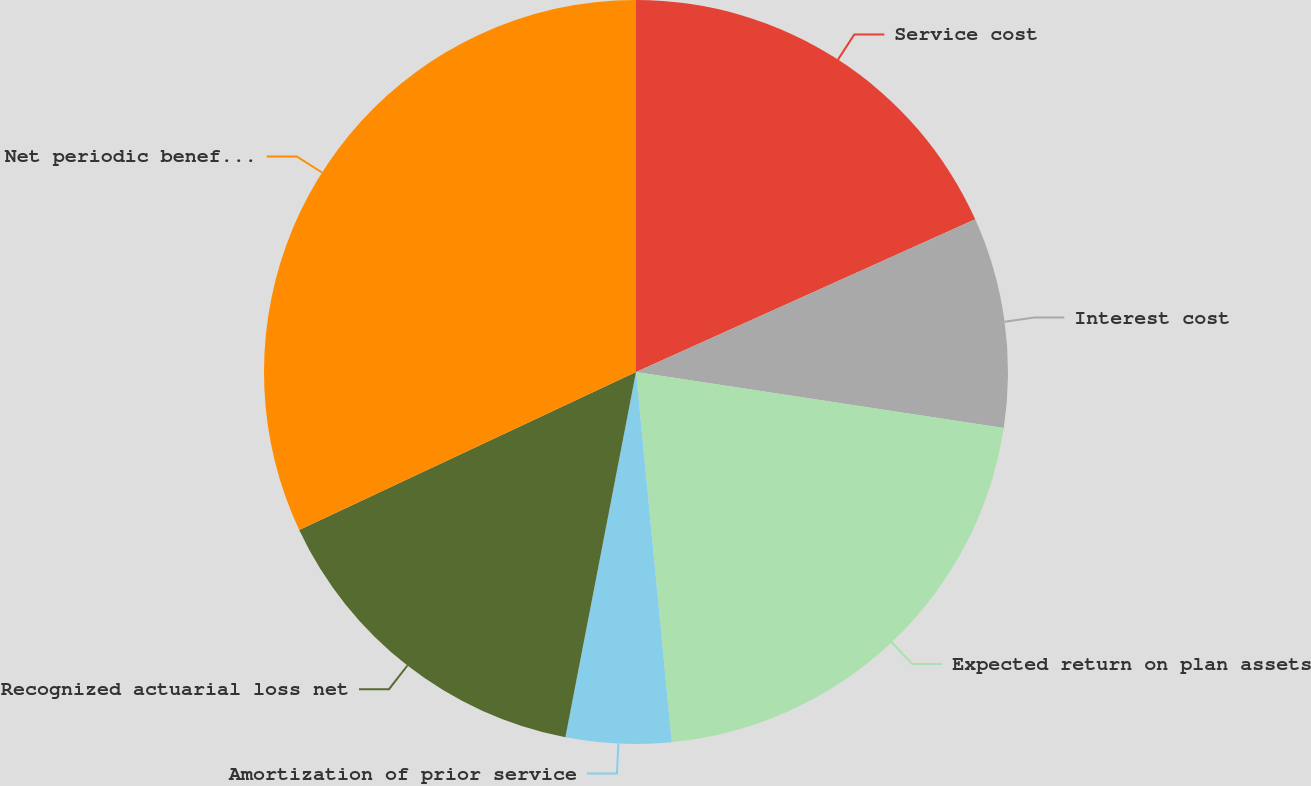<chart> <loc_0><loc_0><loc_500><loc_500><pie_chart><fcel>Service cost<fcel>Interest cost<fcel>Expected return on plan assets<fcel>Amortization of prior service<fcel>Recognized actuarial loss net<fcel>Net periodic benefit cost<nl><fcel>18.27%<fcel>9.14%<fcel>21.06%<fcel>4.57%<fcel>14.98%<fcel>31.98%<nl></chart> 